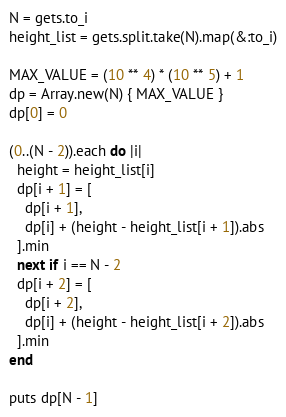<code> <loc_0><loc_0><loc_500><loc_500><_Ruby_>N = gets.to_i
height_list = gets.split.take(N).map(&:to_i)

MAX_VALUE = (10 ** 4) * (10 ** 5) + 1
dp = Array.new(N) { MAX_VALUE }
dp[0] = 0

(0..(N - 2)).each do |i|
  height = height_list[i]
  dp[i + 1] = [
    dp[i + 1],
    dp[i] + (height - height_list[i + 1]).abs
  ].min
  next if i == N - 2
  dp[i + 2] = [
    dp[i + 2],
    dp[i] + (height - height_list[i + 2]).abs
  ].min
end

puts dp[N - 1]
</code> 